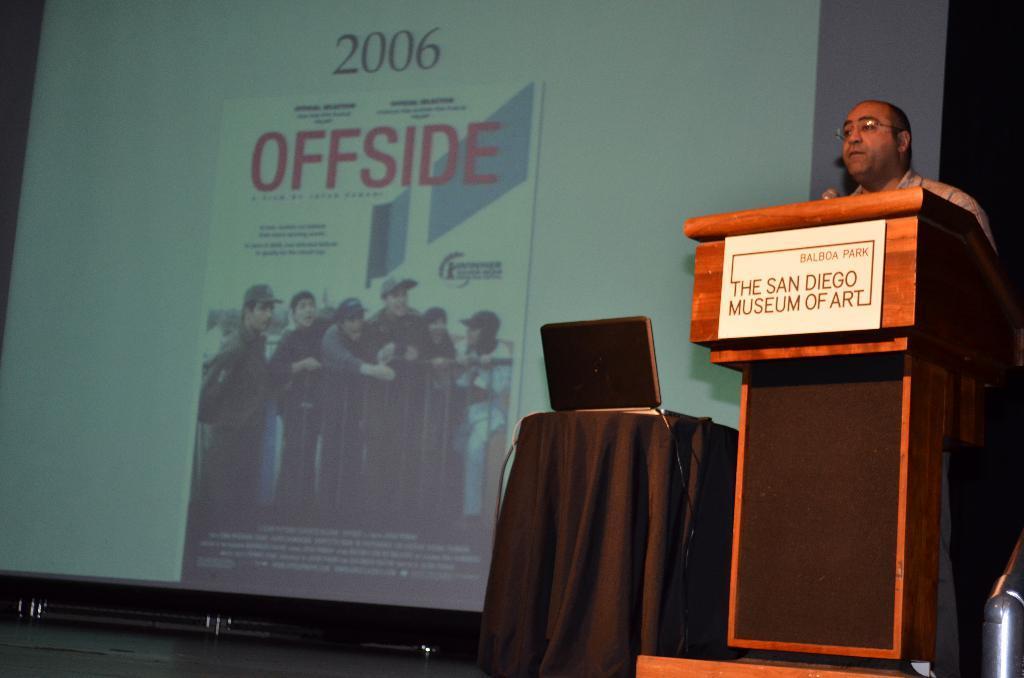Can you describe this image briefly? In the image I can see a person who is standing in front of the desk and bedside there is a laptop on the table and a projector screen. 